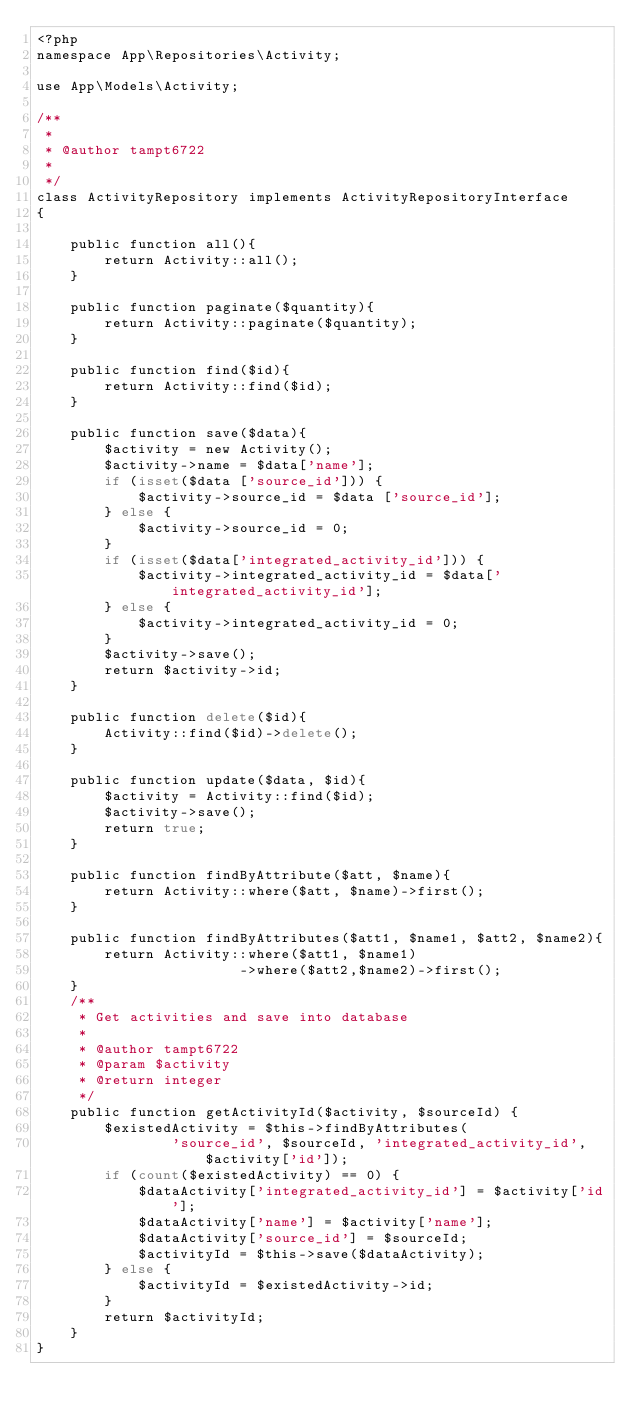<code> <loc_0><loc_0><loc_500><loc_500><_PHP_><?php
namespace App\Repositories\Activity;

use App\Models\Activity;

/**
 *
 * @author tampt6722
 *
 */
class ActivityRepository implements ActivityRepositoryInterface
{

    public function all(){
        return Activity::all();
    }

    public function paginate($quantity){
        return Activity::paginate($quantity);
    }

    public function find($id){
        return Activity::find($id);
    }

    public function save($data){
        $activity = new Activity();
        $activity->name = $data['name'];
        if (isset($data ['source_id'])) {
            $activity->source_id = $data ['source_id'];
        } else {
            $activity->source_id = 0;
        }
        if (isset($data['integrated_activity_id'])) {
            $activity->integrated_activity_id = $data['integrated_activity_id'];
        } else {
            $activity->integrated_activity_id = 0;
        }
        $activity->save();
        return $activity->id;
    }

    public function delete($id){
        Activity::find($id)->delete();
    }

    public function update($data, $id){
        $activity = Activity::find($id);
        $activity->save();
        return true;
    }

    public function findByAttribute($att, $name){
        return Activity::where($att, $name)->first();
    }

    public function findByAttributes($att1, $name1, $att2, $name2){
        return Activity::where($att1, $name1)
                        ->where($att2,$name2)->first();
    }
    /**
     * Get activities and save into database
     *
     * @author tampt6722
     * @param $activity
     * @return integer
     */
    public function getActivityId($activity, $sourceId) {
        $existedActivity = $this->findByAttributes(
                'source_id', $sourceId, 'integrated_activity_id', $activity['id']);
        if (count($existedActivity) == 0) {
            $dataActivity['integrated_activity_id'] = $activity['id'];
            $dataActivity['name'] = $activity['name'];
            $dataActivity['source_id'] = $sourceId;
            $activityId = $this->save($dataActivity);
        } else {
            $activityId = $existedActivity->id;
        }
        return $activityId;
    }
}</code> 